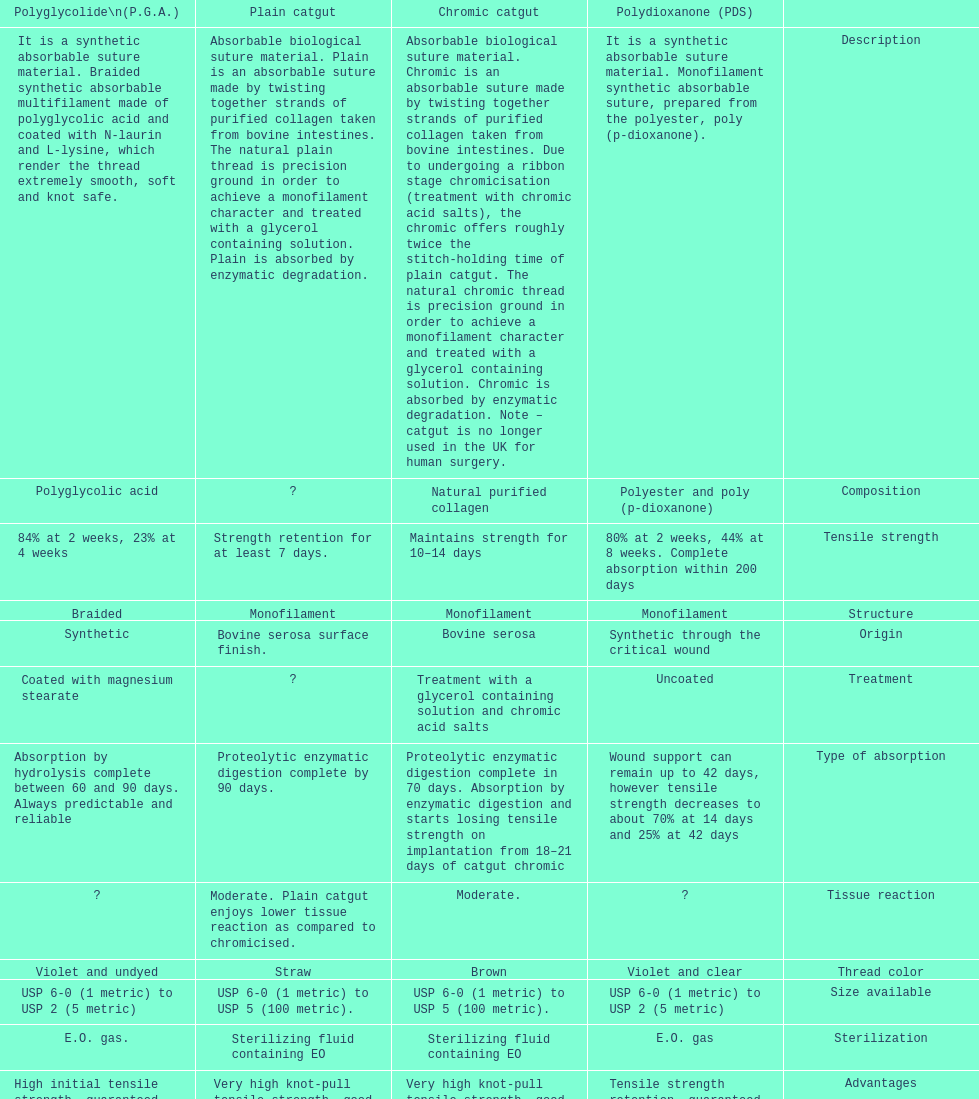What is the total number of suture materials that have a mono-filament structure? 3. 